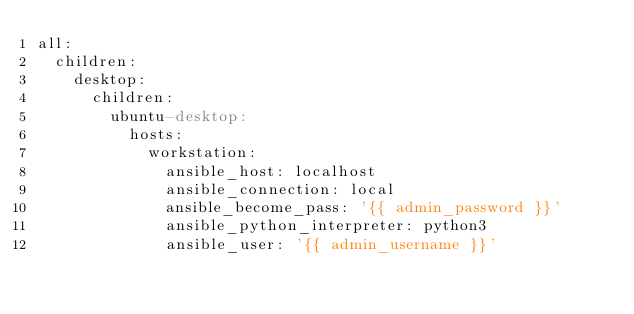Convert code to text. <code><loc_0><loc_0><loc_500><loc_500><_YAML_>all:
  children:
    desktop:
      children:
        ubuntu-desktop:
          hosts:
            workstation:
              ansible_host: localhost
              ansible_connection: local
              ansible_become_pass: '{{ admin_password }}'
              ansible_python_interpreter: python3
              ansible_user: '{{ admin_username }}'
</code> 